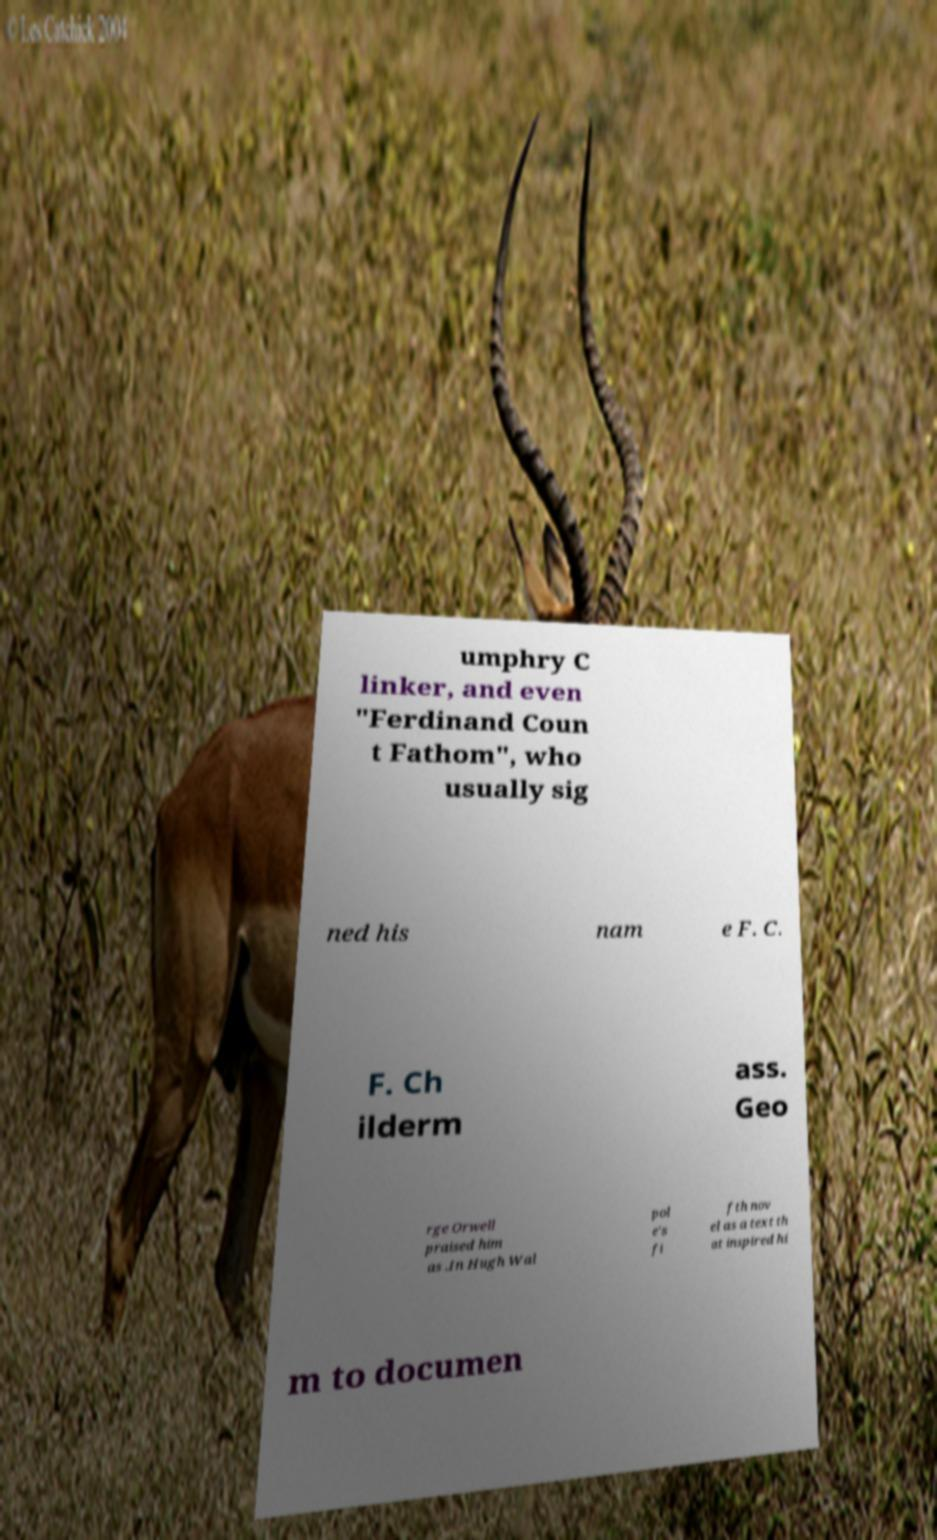Could you extract and type out the text from this image? umphry C linker, and even "Ferdinand Coun t Fathom", who usually sig ned his nam e F. C. F. Ch ilderm ass. Geo rge Orwell praised him as .In Hugh Wal pol e's fi fth nov el as a text th at inspired hi m to documen 